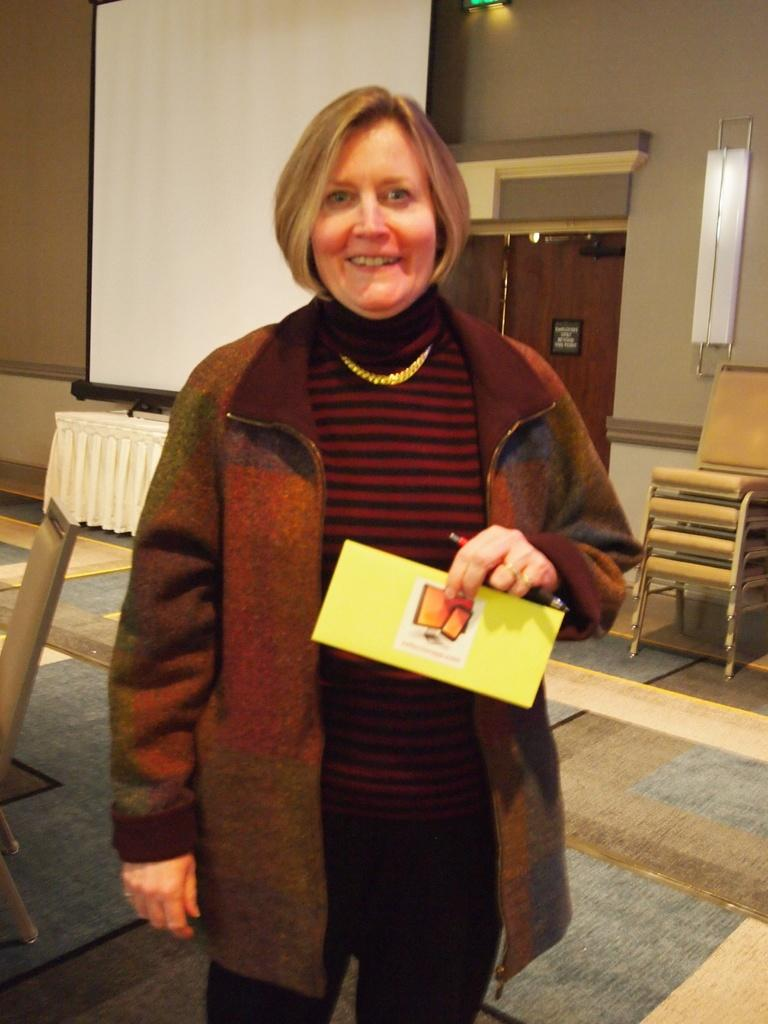What type of structure can be seen in the image? There is a wall in the image. What type of furniture is present in the image? There are chairs in the image. What type of device or surface is visible in the image? There is a screen in the image. Who is present in the image? There is a woman standing in the image. Can you see any ants crawling on the woman's shoes in the image? There are no ants visible in the image. What type of cake is being served on the table in the image? There is no cake present in the image. 